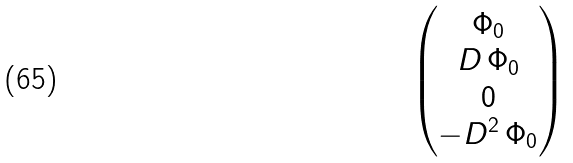<formula> <loc_0><loc_0><loc_500><loc_500>\begin{pmatrix} \Phi _ { 0 } \\ D \, \Phi _ { 0 } \\ 0 \\ - D ^ { 2 } \, \Phi _ { 0 } \end{pmatrix}</formula> 